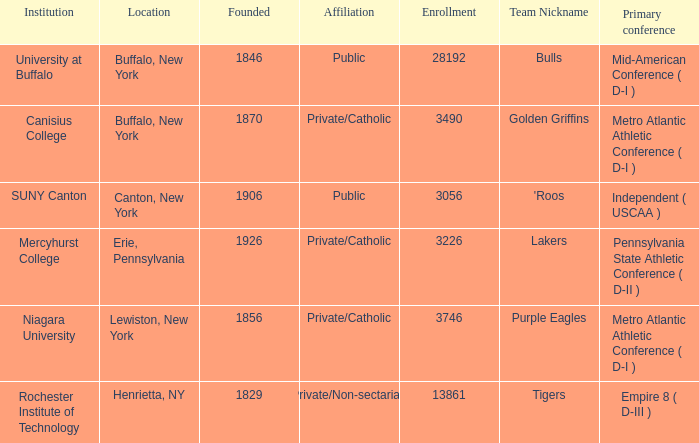What kind of school is Canton, New York? Public. Give me the full table as a dictionary. {'header': ['Institution', 'Location', 'Founded', 'Affiliation', 'Enrollment', 'Team Nickname', 'Primary conference'], 'rows': [['University at Buffalo', 'Buffalo, New York', '1846', 'Public', '28192', 'Bulls', 'Mid-American Conference ( D-I )'], ['Canisius College', 'Buffalo, New York', '1870', 'Private/Catholic', '3490', 'Golden Griffins', 'Metro Atlantic Athletic Conference ( D-I )'], ['SUNY Canton', 'Canton, New York', '1906', 'Public', '3056', "'Roos", 'Independent ( USCAA )'], ['Mercyhurst College', 'Erie, Pennsylvania', '1926', 'Private/Catholic', '3226', 'Lakers', 'Pennsylvania State Athletic Conference ( D-II )'], ['Niagara University', 'Lewiston, New York', '1856', 'Private/Catholic', '3746', 'Purple Eagles', 'Metro Atlantic Athletic Conference ( D-I )'], ['Rochester Institute of Technology', 'Henrietta, NY', '1829', 'Private/Non-sectarian', '13861', 'Tigers', 'Empire 8 ( D-III )']]} 